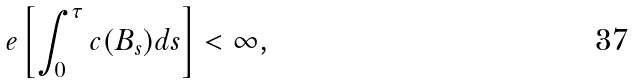<formula> <loc_0><loc_0><loc_500><loc_500>\ e \left [ \int _ { 0 } ^ { \tau } c ( B _ { s } ) d s \right ] < \infty ,</formula> 